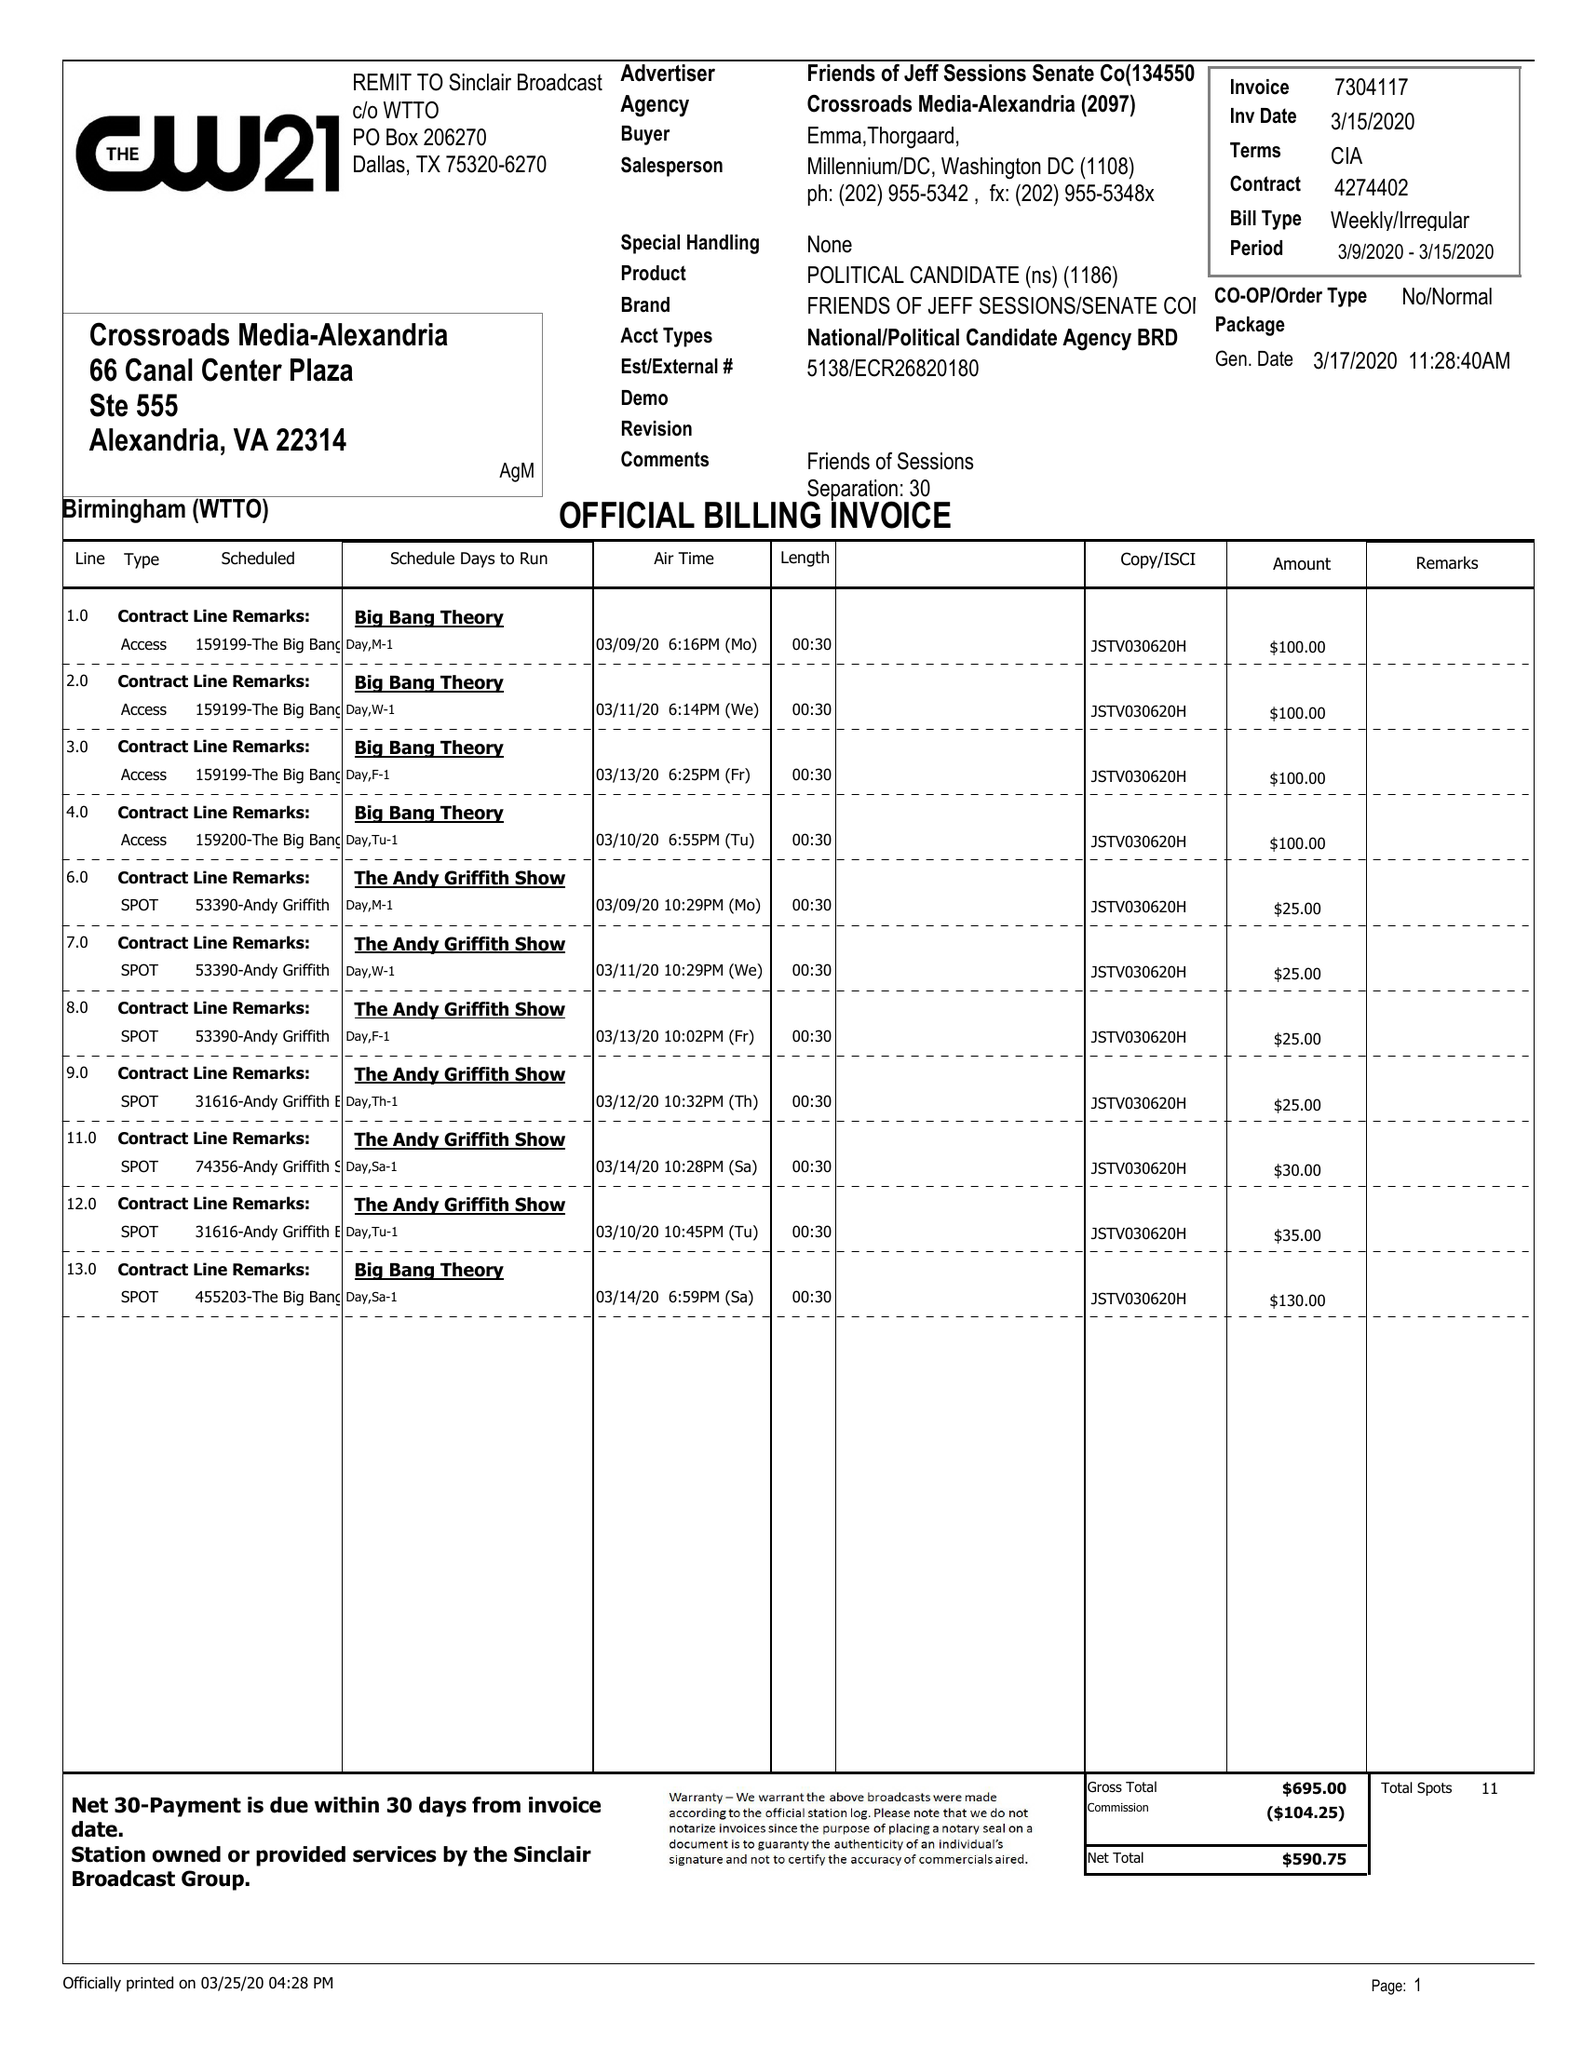What is the value for the flight_from?
Answer the question using a single word or phrase. 03/09/20 